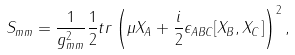Convert formula to latex. <formula><loc_0><loc_0><loc_500><loc_500>S _ { m m } = \frac { 1 } { g _ { m m } ^ { 2 } } \frac { 1 } { 2 } t r \left ( \mu X _ { A } + \frac { i } { 2 } \epsilon _ { A B C } [ X _ { B } , X _ { C } ] \right ) ^ { 2 } ,</formula> 